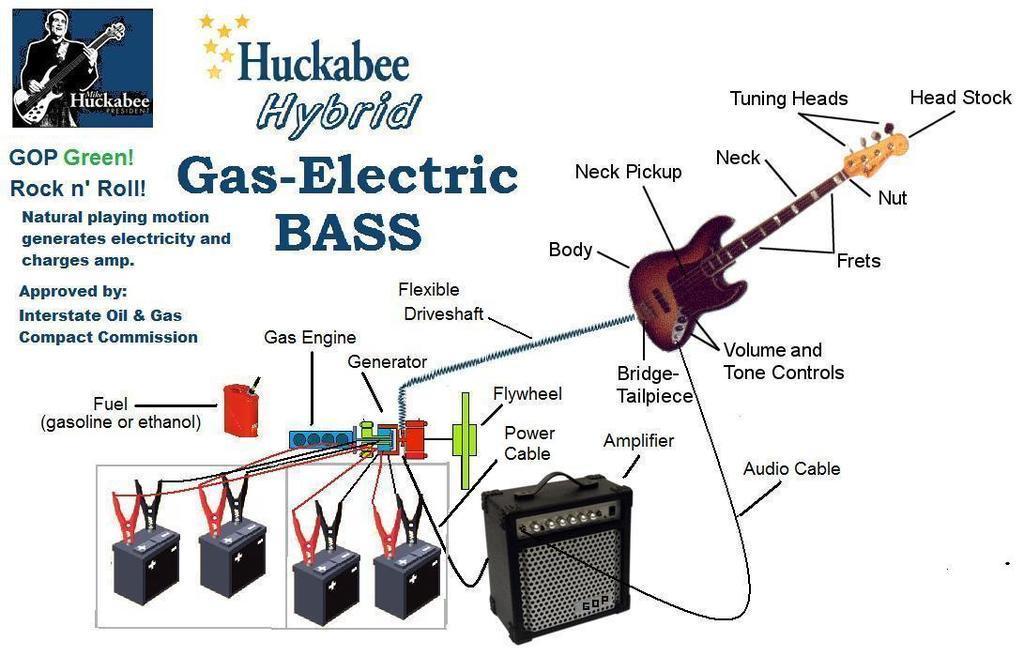How would you summarize this image in a sentence or two? In the picture there is a poster, there are musical instruments present, there is a picture of a person. 